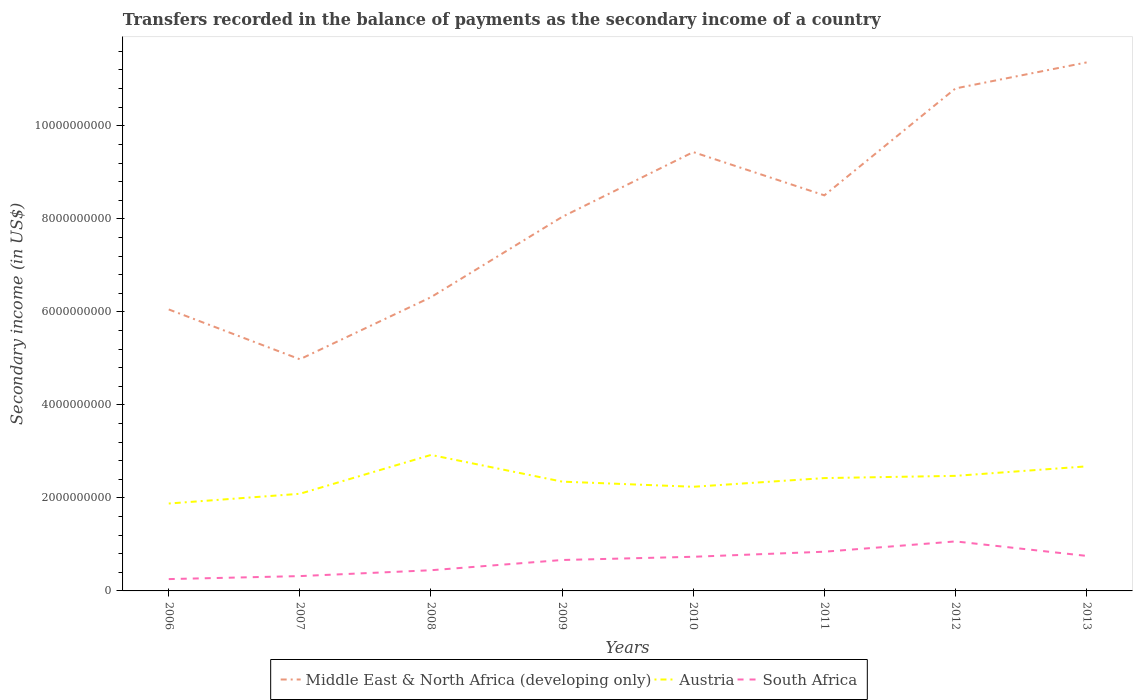Is the number of lines equal to the number of legend labels?
Give a very brief answer. Yes. Across all years, what is the maximum secondary income of in South Africa?
Keep it short and to the point. 2.54e+08. What is the total secondary income of in Middle East & North Africa (developing only) in the graph?
Offer a terse response. -5.31e+09. What is the difference between the highest and the second highest secondary income of in Austria?
Your response must be concise. 1.04e+09. What is the difference between the highest and the lowest secondary income of in Austria?
Offer a very short reply. 4. Is the secondary income of in Middle East & North Africa (developing only) strictly greater than the secondary income of in Austria over the years?
Make the answer very short. No. How many lines are there?
Your answer should be compact. 3. Does the graph contain any zero values?
Make the answer very short. No. How many legend labels are there?
Offer a terse response. 3. How are the legend labels stacked?
Your answer should be very brief. Horizontal. What is the title of the graph?
Offer a very short reply. Transfers recorded in the balance of payments as the secondary income of a country. Does "St. Kitts and Nevis" appear as one of the legend labels in the graph?
Your response must be concise. No. What is the label or title of the Y-axis?
Your answer should be very brief. Secondary income (in US$). What is the Secondary income (in US$) of Middle East & North Africa (developing only) in 2006?
Provide a succinct answer. 6.05e+09. What is the Secondary income (in US$) in Austria in 2006?
Provide a short and direct response. 1.88e+09. What is the Secondary income (in US$) of South Africa in 2006?
Ensure brevity in your answer.  2.54e+08. What is the Secondary income (in US$) of Middle East & North Africa (developing only) in 2007?
Your answer should be compact. 4.98e+09. What is the Secondary income (in US$) in Austria in 2007?
Your answer should be compact. 2.09e+09. What is the Secondary income (in US$) in South Africa in 2007?
Make the answer very short. 3.19e+08. What is the Secondary income (in US$) in Middle East & North Africa (developing only) in 2008?
Provide a succinct answer. 6.32e+09. What is the Secondary income (in US$) of Austria in 2008?
Your answer should be compact. 2.92e+09. What is the Secondary income (in US$) of South Africa in 2008?
Your response must be concise. 4.45e+08. What is the Secondary income (in US$) in Middle East & North Africa (developing only) in 2009?
Offer a terse response. 8.04e+09. What is the Secondary income (in US$) of Austria in 2009?
Provide a short and direct response. 2.35e+09. What is the Secondary income (in US$) of South Africa in 2009?
Make the answer very short. 6.65e+08. What is the Secondary income (in US$) of Middle East & North Africa (developing only) in 2010?
Your answer should be very brief. 9.43e+09. What is the Secondary income (in US$) of Austria in 2010?
Make the answer very short. 2.24e+09. What is the Secondary income (in US$) in South Africa in 2010?
Make the answer very short. 7.34e+08. What is the Secondary income (in US$) of Middle East & North Africa (developing only) in 2011?
Make the answer very short. 8.50e+09. What is the Secondary income (in US$) of Austria in 2011?
Your answer should be very brief. 2.43e+09. What is the Secondary income (in US$) in South Africa in 2011?
Provide a succinct answer. 8.43e+08. What is the Secondary income (in US$) of Middle East & North Africa (developing only) in 2012?
Your answer should be compact. 1.08e+1. What is the Secondary income (in US$) in Austria in 2012?
Give a very brief answer. 2.47e+09. What is the Secondary income (in US$) of South Africa in 2012?
Give a very brief answer. 1.06e+09. What is the Secondary income (in US$) in Middle East & North Africa (developing only) in 2013?
Keep it short and to the point. 1.14e+1. What is the Secondary income (in US$) of Austria in 2013?
Make the answer very short. 2.68e+09. What is the Secondary income (in US$) in South Africa in 2013?
Give a very brief answer. 7.53e+08. Across all years, what is the maximum Secondary income (in US$) in Middle East & North Africa (developing only)?
Keep it short and to the point. 1.14e+1. Across all years, what is the maximum Secondary income (in US$) of Austria?
Your response must be concise. 2.92e+09. Across all years, what is the maximum Secondary income (in US$) in South Africa?
Your answer should be very brief. 1.06e+09. Across all years, what is the minimum Secondary income (in US$) of Middle East & North Africa (developing only)?
Provide a succinct answer. 4.98e+09. Across all years, what is the minimum Secondary income (in US$) of Austria?
Offer a very short reply. 1.88e+09. Across all years, what is the minimum Secondary income (in US$) in South Africa?
Keep it short and to the point. 2.54e+08. What is the total Secondary income (in US$) of Middle East & North Africa (developing only) in the graph?
Give a very brief answer. 6.55e+1. What is the total Secondary income (in US$) of Austria in the graph?
Your response must be concise. 1.91e+1. What is the total Secondary income (in US$) of South Africa in the graph?
Your response must be concise. 5.08e+09. What is the difference between the Secondary income (in US$) in Middle East & North Africa (developing only) in 2006 and that in 2007?
Ensure brevity in your answer.  1.07e+09. What is the difference between the Secondary income (in US$) in Austria in 2006 and that in 2007?
Ensure brevity in your answer.  -2.09e+08. What is the difference between the Secondary income (in US$) in South Africa in 2006 and that in 2007?
Provide a short and direct response. -6.44e+07. What is the difference between the Secondary income (in US$) in Middle East & North Africa (developing only) in 2006 and that in 2008?
Ensure brevity in your answer.  -2.64e+08. What is the difference between the Secondary income (in US$) in Austria in 2006 and that in 2008?
Your response must be concise. -1.04e+09. What is the difference between the Secondary income (in US$) in South Africa in 2006 and that in 2008?
Offer a terse response. -1.90e+08. What is the difference between the Secondary income (in US$) of Middle East & North Africa (developing only) in 2006 and that in 2009?
Ensure brevity in your answer.  -1.99e+09. What is the difference between the Secondary income (in US$) in Austria in 2006 and that in 2009?
Offer a terse response. -4.71e+08. What is the difference between the Secondary income (in US$) of South Africa in 2006 and that in 2009?
Provide a succinct answer. -4.10e+08. What is the difference between the Secondary income (in US$) in Middle East & North Africa (developing only) in 2006 and that in 2010?
Keep it short and to the point. -3.38e+09. What is the difference between the Secondary income (in US$) in Austria in 2006 and that in 2010?
Keep it short and to the point. -3.60e+08. What is the difference between the Secondary income (in US$) of South Africa in 2006 and that in 2010?
Provide a succinct answer. -4.80e+08. What is the difference between the Secondary income (in US$) of Middle East & North Africa (developing only) in 2006 and that in 2011?
Provide a short and direct response. -2.45e+09. What is the difference between the Secondary income (in US$) of Austria in 2006 and that in 2011?
Provide a short and direct response. -5.47e+08. What is the difference between the Secondary income (in US$) in South Africa in 2006 and that in 2011?
Offer a terse response. -5.89e+08. What is the difference between the Secondary income (in US$) of Middle East & North Africa (developing only) in 2006 and that in 2012?
Ensure brevity in your answer.  -4.75e+09. What is the difference between the Secondary income (in US$) in Austria in 2006 and that in 2012?
Offer a very short reply. -5.95e+08. What is the difference between the Secondary income (in US$) in South Africa in 2006 and that in 2012?
Ensure brevity in your answer.  -8.10e+08. What is the difference between the Secondary income (in US$) of Middle East & North Africa (developing only) in 2006 and that in 2013?
Offer a terse response. -5.31e+09. What is the difference between the Secondary income (in US$) of Austria in 2006 and that in 2013?
Make the answer very short. -7.99e+08. What is the difference between the Secondary income (in US$) of South Africa in 2006 and that in 2013?
Ensure brevity in your answer.  -4.99e+08. What is the difference between the Secondary income (in US$) of Middle East & North Africa (developing only) in 2007 and that in 2008?
Provide a short and direct response. -1.34e+09. What is the difference between the Secondary income (in US$) in Austria in 2007 and that in 2008?
Provide a succinct answer. -8.35e+08. What is the difference between the Secondary income (in US$) in South Africa in 2007 and that in 2008?
Your answer should be very brief. -1.26e+08. What is the difference between the Secondary income (in US$) in Middle East & North Africa (developing only) in 2007 and that in 2009?
Keep it short and to the point. -3.06e+09. What is the difference between the Secondary income (in US$) of Austria in 2007 and that in 2009?
Provide a succinct answer. -2.61e+08. What is the difference between the Secondary income (in US$) of South Africa in 2007 and that in 2009?
Offer a terse response. -3.46e+08. What is the difference between the Secondary income (in US$) in Middle East & North Africa (developing only) in 2007 and that in 2010?
Ensure brevity in your answer.  -4.45e+09. What is the difference between the Secondary income (in US$) of Austria in 2007 and that in 2010?
Your answer should be very brief. -1.51e+08. What is the difference between the Secondary income (in US$) in South Africa in 2007 and that in 2010?
Keep it short and to the point. -4.15e+08. What is the difference between the Secondary income (in US$) of Middle East & North Africa (developing only) in 2007 and that in 2011?
Your answer should be compact. -3.52e+09. What is the difference between the Secondary income (in US$) of Austria in 2007 and that in 2011?
Your answer should be compact. -3.38e+08. What is the difference between the Secondary income (in US$) of South Africa in 2007 and that in 2011?
Offer a terse response. -5.24e+08. What is the difference between the Secondary income (in US$) in Middle East & North Africa (developing only) in 2007 and that in 2012?
Make the answer very short. -5.82e+09. What is the difference between the Secondary income (in US$) of Austria in 2007 and that in 2012?
Give a very brief answer. -3.85e+08. What is the difference between the Secondary income (in US$) in South Africa in 2007 and that in 2012?
Your response must be concise. -7.46e+08. What is the difference between the Secondary income (in US$) of Middle East & North Africa (developing only) in 2007 and that in 2013?
Your answer should be very brief. -6.38e+09. What is the difference between the Secondary income (in US$) in Austria in 2007 and that in 2013?
Make the answer very short. -5.90e+08. What is the difference between the Secondary income (in US$) in South Africa in 2007 and that in 2013?
Offer a very short reply. -4.34e+08. What is the difference between the Secondary income (in US$) in Middle East & North Africa (developing only) in 2008 and that in 2009?
Make the answer very short. -1.73e+09. What is the difference between the Secondary income (in US$) in Austria in 2008 and that in 2009?
Offer a terse response. 5.74e+08. What is the difference between the Secondary income (in US$) in South Africa in 2008 and that in 2009?
Your answer should be compact. -2.20e+08. What is the difference between the Secondary income (in US$) of Middle East & North Africa (developing only) in 2008 and that in 2010?
Provide a short and direct response. -3.12e+09. What is the difference between the Secondary income (in US$) of Austria in 2008 and that in 2010?
Offer a terse response. 6.85e+08. What is the difference between the Secondary income (in US$) in South Africa in 2008 and that in 2010?
Make the answer very short. -2.90e+08. What is the difference between the Secondary income (in US$) in Middle East & North Africa (developing only) in 2008 and that in 2011?
Keep it short and to the point. -2.19e+09. What is the difference between the Secondary income (in US$) of Austria in 2008 and that in 2011?
Ensure brevity in your answer.  4.98e+08. What is the difference between the Secondary income (in US$) in South Africa in 2008 and that in 2011?
Keep it short and to the point. -3.98e+08. What is the difference between the Secondary income (in US$) of Middle East & North Africa (developing only) in 2008 and that in 2012?
Provide a short and direct response. -4.49e+09. What is the difference between the Secondary income (in US$) in Austria in 2008 and that in 2012?
Give a very brief answer. 4.50e+08. What is the difference between the Secondary income (in US$) in South Africa in 2008 and that in 2012?
Give a very brief answer. -6.20e+08. What is the difference between the Secondary income (in US$) of Middle East & North Africa (developing only) in 2008 and that in 2013?
Keep it short and to the point. -5.05e+09. What is the difference between the Secondary income (in US$) in Austria in 2008 and that in 2013?
Make the answer very short. 2.46e+08. What is the difference between the Secondary income (in US$) of South Africa in 2008 and that in 2013?
Your answer should be very brief. -3.08e+08. What is the difference between the Secondary income (in US$) in Middle East & North Africa (developing only) in 2009 and that in 2010?
Your answer should be very brief. -1.39e+09. What is the difference between the Secondary income (in US$) of Austria in 2009 and that in 2010?
Your answer should be compact. 1.11e+08. What is the difference between the Secondary income (in US$) in South Africa in 2009 and that in 2010?
Offer a very short reply. -6.94e+07. What is the difference between the Secondary income (in US$) of Middle East & North Africa (developing only) in 2009 and that in 2011?
Keep it short and to the point. -4.64e+08. What is the difference between the Secondary income (in US$) in Austria in 2009 and that in 2011?
Keep it short and to the point. -7.61e+07. What is the difference between the Secondary income (in US$) of South Africa in 2009 and that in 2011?
Make the answer very short. -1.78e+08. What is the difference between the Secondary income (in US$) in Middle East & North Africa (developing only) in 2009 and that in 2012?
Ensure brevity in your answer.  -2.76e+09. What is the difference between the Secondary income (in US$) of Austria in 2009 and that in 2012?
Your response must be concise. -1.24e+08. What is the difference between the Secondary income (in US$) of South Africa in 2009 and that in 2012?
Provide a succinct answer. -4.00e+08. What is the difference between the Secondary income (in US$) of Middle East & North Africa (developing only) in 2009 and that in 2013?
Your answer should be very brief. -3.32e+09. What is the difference between the Secondary income (in US$) of Austria in 2009 and that in 2013?
Offer a very short reply. -3.28e+08. What is the difference between the Secondary income (in US$) of South Africa in 2009 and that in 2013?
Offer a very short reply. -8.82e+07. What is the difference between the Secondary income (in US$) of Middle East & North Africa (developing only) in 2010 and that in 2011?
Your response must be concise. 9.30e+08. What is the difference between the Secondary income (in US$) of Austria in 2010 and that in 2011?
Your response must be concise. -1.87e+08. What is the difference between the Secondary income (in US$) in South Africa in 2010 and that in 2011?
Your answer should be very brief. -1.09e+08. What is the difference between the Secondary income (in US$) in Middle East & North Africa (developing only) in 2010 and that in 2012?
Your answer should be compact. -1.37e+09. What is the difference between the Secondary income (in US$) of Austria in 2010 and that in 2012?
Your answer should be very brief. -2.35e+08. What is the difference between the Secondary income (in US$) in South Africa in 2010 and that in 2012?
Offer a very short reply. -3.30e+08. What is the difference between the Secondary income (in US$) of Middle East & North Africa (developing only) in 2010 and that in 2013?
Your response must be concise. -1.93e+09. What is the difference between the Secondary income (in US$) in Austria in 2010 and that in 2013?
Make the answer very short. -4.39e+08. What is the difference between the Secondary income (in US$) in South Africa in 2010 and that in 2013?
Offer a very short reply. -1.88e+07. What is the difference between the Secondary income (in US$) of Middle East & North Africa (developing only) in 2011 and that in 2012?
Keep it short and to the point. -2.30e+09. What is the difference between the Secondary income (in US$) in Austria in 2011 and that in 2012?
Your answer should be compact. -4.79e+07. What is the difference between the Secondary income (in US$) of South Africa in 2011 and that in 2012?
Give a very brief answer. -2.21e+08. What is the difference between the Secondary income (in US$) of Middle East & North Africa (developing only) in 2011 and that in 2013?
Keep it short and to the point. -2.86e+09. What is the difference between the Secondary income (in US$) in Austria in 2011 and that in 2013?
Provide a short and direct response. -2.52e+08. What is the difference between the Secondary income (in US$) in South Africa in 2011 and that in 2013?
Keep it short and to the point. 9.01e+07. What is the difference between the Secondary income (in US$) of Middle East & North Africa (developing only) in 2012 and that in 2013?
Offer a very short reply. -5.59e+08. What is the difference between the Secondary income (in US$) of Austria in 2012 and that in 2013?
Give a very brief answer. -2.04e+08. What is the difference between the Secondary income (in US$) of South Africa in 2012 and that in 2013?
Offer a terse response. 3.11e+08. What is the difference between the Secondary income (in US$) in Middle East & North Africa (developing only) in 2006 and the Secondary income (in US$) in Austria in 2007?
Give a very brief answer. 3.96e+09. What is the difference between the Secondary income (in US$) of Middle East & North Africa (developing only) in 2006 and the Secondary income (in US$) of South Africa in 2007?
Your response must be concise. 5.73e+09. What is the difference between the Secondary income (in US$) in Austria in 2006 and the Secondary income (in US$) in South Africa in 2007?
Offer a very short reply. 1.56e+09. What is the difference between the Secondary income (in US$) of Middle East & North Africa (developing only) in 2006 and the Secondary income (in US$) of Austria in 2008?
Provide a succinct answer. 3.13e+09. What is the difference between the Secondary income (in US$) of Middle East & North Africa (developing only) in 2006 and the Secondary income (in US$) of South Africa in 2008?
Provide a succinct answer. 5.61e+09. What is the difference between the Secondary income (in US$) of Austria in 2006 and the Secondary income (in US$) of South Africa in 2008?
Provide a succinct answer. 1.43e+09. What is the difference between the Secondary income (in US$) of Middle East & North Africa (developing only) in 2006 and the Secondary income (in US$) of Austria in 2009?
Your response must be concise. 3.70e+09. What is the difference between the Secondary income (in US$) of Middle East & North Africa (developing only) in 2006 and the Secondary income (in US$) of South Africa in 2009?
Offer a very short reply. 5.39e+09. What is the difference between the Secondary income (in US$) of Austria in 2006 and the Secondary income (in US$) of South Africa in 2009?
Your answer should be very brief. 1.21e+09. What is the difference between the Secondary income (in US$) in Middle East & North Africa (developing only) in 2006 and the Secondary income (in US$) in Austria in 2010?
Ensure brevity in your answer.  3.81e+09. What is the difference between the Secondary income (in US$) in Middle East & North Africa (developing only) in 2006 and the Secondary income (in US$) in South Africa in 2010?
Provide a short and direct response. 5.32e+09. What is the difference between the Secondary income (in US$) in Austria in 2006 and the Secondary income (in US$) in South Africa in 2010?
Offer a very short reply. 1.14e+09. What is the difference between the Secondary income (in US$) of Middle East & North Africa (developing only) in 2006 and the Secondary income (in US$) of Austria in 2011?
Provide a succinct answer. 3.63e+09. What is the difference between the Secondary income (in US$) in Middle East & North Africa (developing only) in 2006 and the Secondary income (in US$) in South Africa in 2011?
Give a very brief answer. 5.21e+09. What is the difference between the Secondary income (in US$) of Austria in 2006 and the Secondary income (in US$) of South Africa in 2011?
Offer a very short reply. 1.04e+09. What is the difference between the Secondary income (in US$) in Middle East & North Africa (developing only) in 2006 and the Secondary income (in US$) in Austria in 2012?
Provide a short and direct response. 3.58e+09. What is the difference between the Secondary income (in US$) in Middle East & North Africa (developing only) in 2006 and the Secondary income (in US$) in South Africa in 2012?
Ensure brevity in your answer.  4.99e+09. What is the difference between the Secondary income (in US$) of Austria in 2006 and the Secondary income (in US$) of South Africa in 2012?
Your answer should be compact. 8.15e+08. What is the difference between the Secondary income (in US$) of Middle East & North Africa (developing only) in 2006 and the Secondary income (in US$) of Austria in 2013?
Your answer should be compact. 3.37e+09. What is the difference between the Secondary income (in US$) in Middle East & North Africa (developing only) in 2006 and the Secondary income (in US$) in South Africa in 2013?
Keep it short and to the point. 5.30e+09. What is the difference between the Secondary income (in US$) of Austria in 2006 and the Secondary income (in US$) of South Africa in 2013?
Your answer should be compact. 1.13e+09. What is the difference between the Secondary income (in US$) of Middle East & North Africa (developing only) in 2007 and the Secondary income (in US$) of Austria in 2008?
Your response must be concise. 2.06e+09. What is the difference between the Secondary income (in US$) of Middle East & North Africa (developing only) in 2007 and the Secondary income (in US$) of South Africa in 2008?
Offer a very short reply. 4.54e+09. What is the difference between the Secondary income (in US$) in Austria in 2007 and the Secondary income (in US$) in South Africa in 2008?
Keep it short and to the point. 1.64e+09. What is the difference between the Secondary income (in US$) of Middle East & North Africa (developing only) in 2007 and the Secondary income (in US$) of Austria in 2009?
Your response must be concise. 2.63e+09. What is the difference between the Secondary income (in US$) of Middle East & North Africa (developing only) in 2007 and the Secondary income (in US$) of South Africa in 2009?
Offer a very short reply. 4.32e+09. What is the difference between the Secondary income (in US$) of Austria in 2007 and the Secondary income (in US$) of South Africa in 2009?
Provide a succinct answer. 1.42e+09. What is the difference between the Secondary income (in US$) in Middle East & North Africa (developing only) in 2007 and the Secondary income (in US$) in Austria in 2010?
Your answer should be very brief. 2.74e+09. What is the difference between the Secondary income (in US$) of Middle East & North Africa (developing only) in 2007 and the Secondary income (in US$) of South Africa in 2010?
Give a very brief answer. 4.25e+09. What is the difference between the Secondary income (in US$) in Austria in 2007 and the Secondary income (in US$) in South Africa in 2010?
Provide a short and direct response. 1.35e+09. What is the difference between the Secondary income (in US$) of Middle East & North Africa (developing only) in 2007 and the Secondary income (in US$) of Austria in 2011?
Your answer should be compact. 2.55e+09. What is the difference between the Secondary income (in US$) in Middle East & North Africa (developing only) in 2007 and the Secondary income (in US$) in South Africa in 2011?
Ensure brevity in your answer.  4.14e+09. What is the difference between the Secondary income (in US$) of Austria in 2007 and the Secondary income (in US$) of South Africa in 2011?
Keep it short and to the point. 1.25e+09. What is the difference between the Secondary income (in US$) in Middle East & North Africa (developing only) in 2007 and the Secondary income (in US$) in Austria in 2012?
Your answer should be compact. 2.51e+09. What is the difference between the Secondary income (in US$) in Middle East & North Africa (developing only) in 2007 and the Secondary income (in US$) in South Africa in 2012?
Offer a terse response. 3.92e+09. What is the difference between the Secondary income (in US$) of Austria in 2007 and the Secondary income (in US$) of South Africa in 2012?
Make the answer very short. 1.02e+09. What is the difference between the Secondary income (in US$) of Middle East & North Africa (developing only) in 2007 and the Secondary income (in US$) of Austria in 2013?
Keep it short and to the point. 2.30e+09. What is the difference between the Secondary income (in US$) of Middle East & North Africa (developing only) in 2007 and the Secondary income (in US$) of South Africa in 2013?
Your answer should be very brief. 4.23e+09. What is the difference between the Secondary income (in US$) of Austria in 2007 and the Secondary income (in US$) of South Africa in 2013?
Your response must be concise. 1.34e+09. What is the difference between the Secondary income (in US$) of Middle East & North Africa (developing only) in 2008 and the Secondary income (in US$) of Austria in 2009?
Provide a short and direct response. 3.97e+09. What is the difference between the Secondary income (in US$) in Middle East & North Africa (developing only) in 2008 and the Secondary income (in US$) in South Africa in 2009?
Keep it short and to the point. 5.65e+09. What is the difference between the Secondary income (in US$) of Austria in 2008 and the Secondary income (in US$) of South Africa in 2009?
Ensure brevity in your answer.  2.26e+09. What is the difference between the Secondary income (in US$) of Middle East & North Africa (developing only) in 2008 and the Secondary income (in US$) of Austria in 2010?
Keep it short and to the point. 4.08e+09. What is the difference between the Secondary income (in US$) of Middle East & North Africa (developing only) in 2008 and the Secondary income (in US$) of South Africa in 2010?
Give a very brief answer. 5.58e+09. What is the difference between the Secondary income (in US$) of Austria in 2008 and the Secondary income (in US$) of South Africa in 2010?
Your response must be concise. 2.19e+09. What is the difference between the Secondary income (in US$) in Middle East & North Africa (developing only) in 2008 and the Secondary income (in US$) in Austria in 2011?
Provide a succinct answer. 3.89e+09. What is the difference between the Secondary income (in US$) of Middle East & North Africa (developing only) in 2008 and the Secondary income (in US$) of South Africa in 2011?
Offer a terse response. 5.47e+09. What is the difference between the Secondary income (in US$) in Austria in 2008 and the Secondary income (in US$) in South Africa in 2011?
Ensure brevity in your answer.  2.08e+09. What is the difference between the Secondary income (in US$) of Middle East & North Africa (developing only) in 2008 and the Secondary income (in US$) of Austria in 2012?
Keep it short and to the point. 3.84e+09. What is the difference between the Secondary income (in US$) of Middle East & North Africa (developing only) in 2008 and the Secondary income (in US$) of South Africa in 2012?
Ensure brevity in your answer.  5.25e+09. What is the difference between the Secondary income (in US$) of Austria in 2008 and the Secondary income (in US$) of South Africa in 2012?
Give a very brief answer. 1.86e+09. What is the difference between the Secondary income (in US$) in Middle East & North Africa (developing only) in 2008 and the Secondary income (in US$) in Austria in 2013?
Provide a succinct answer. 3.64e+09. What is the difference between the Secondary income (in US$) in Middle East & North Africa (developing only) in 2008 and the Secondary income (in US$) in South Africa in 2013?
Offer a very short reply. 5.56e+09. What is the difference between the Secondary income (in US$) of Austria in 2008 and the Secondary income (in US$) of South Africa in 2013?
Provide a succinct answer. 2.17e+09. What is the difference between the Secondary income (in US$) in Middle East & North Africa (developing only) in 2009 and the Secondary income (in US$) in Austria in 2010?
Provide a succinct answer. 5.80e+09. What is the difference between the Secondary income (in US$) of Middle East & North Africa (developing only) in 2009 and the Secondary income (in US$) of South Africa in 2010?
Your answer should be very brief. 7.31e+09. What is the difference between the Secondary income (in US$) in Austria in 2009 and the Secondary income (in US$) in South Africa in 2010?
Keep it short and to the point. 1.62e+09. What is the difference between the Secondary income (in US$) in Middle East & North Africa (developing only) in 2009 and the Secondary income (in US$) in Austria in 2011?
Your answer should be very brief. 5.62e+09. What is the difference between the Secondary income (in US$) in Middle East & North Africa (developing only) in 2009 and the Secondary income (in US$) in South Africa in 2011?
Offer a terse response. 7.20e+09. What is the difference between the Secondary income (in US$) of Austria in 2009 and the Secondary income (in US$) of South Africa in 2011?
Offer a terse response. 1.51e+09. What is the difference between the Secondary income (in US$) of Middle East & North Africa (developing only) in 2009 and the Secondary income (in US$) of Austria in 2012?
Provide a succinct answer. 5.57e+09. What is the difference between the Secondary income (in US$) of Middle East & North Africa (developing only) in 2009 and the Secondary income (in US$) of South Africa in 2012?
Ensure brevity in your answer.  6.98e+09. What is the difference between the Secondary income (in US$) in Austria in 2009 and the Secondary income (in US$) in South Africa in 2012?
Ensure brevity in your answer.  1.29e+09. What is the difference between the Secondary income (in US$) in Middle East & North Africa (developing only) in 2009 and the Secondary income (in US$) in Austria in 2013?
Make the answer very short. 5.36e+09. What is the difference between the Secondary income (in US$) in Middle East & North Africa (developing only) in 2009 and the Secondary income (in US$) in South Africa in 2013?
Make the answer very short. 7.29e+09. What is the difference between the Secondary income (in US$) in Austria in 2009 and the Secondary income (in US$) in South Africa in 2013?
Give a very brief answer. 1.60e+09. What is the difference between the Secondary income (in US$) in Middle East & North Africa (developing only) in 2010 and the Secondary income (in US$) in Austria in 2011?
Keep it short and to the point. 7.01e+09. What is the difference between the Secondary income (in US$) in Middle East & North Africa (developing only) in 2010 and the Secondary income (in US$) in South Africa in 2011?
Your answer should be compact. 8.59e+09. What is the difference between the Secondary income (in US$) of Austria in 2010 and the Secondary income (in US$) of South Africa in 2011?
Offer a very short reply. 1.40e+09. What is the difference between the Secondary income (in US$) of Middle East & North Africa (developing only) in 2010 and the Secondary income (in US$) of Austria in 2012?
Your answer should be very brief. 6.96e+09. What is the difference between the Secondary income (in US$) in Middle East & North Africa (developing only) in 2010 and the Secondary income (in US$) in South Africa in 2012?
Your response must be concise. 8.37e+09. What is the difference between the Secondary income (in US$) of Austria in 2010 and the Secondary income (in US$) of South Africa in 2012?
Offer a very short reply. 1.17e+09. What is the difference between the Secondary income (in US$) in Middle East & North Africa (developing only) in 2010 and the Secondary income (in US$) in Austria in 2013?
Offer a terse response. 6.76e+09. What is the difference between the Secondary income (in US$) in Middle East & North Africa (developing only) in 2010 and the Secondary income (in US$) in South Africa in 2013?
Make the answer very short. 8.68e+09. What is the difference between the Secondary income (in US$) of Austria in 2010 and the Secondary income (in US$) of South Africa in 2013?
Provide a short and direct response. 1.49e+09. What is the difference between the Secondary income (in US$) in Middle East & North Africa (developing only) in 2011 and the Secondary income (in US$) in Austria in 2012?
Your response must be concise. 6.03e+09. What is the difference between the Secondary income (in US$) of Middle East & North Africa (developing only) in 2011 and the Secondary income (in US$) of South Africa in 2012?
Your answer should be compact. 7.44e+09. What is the difference between the Secondary income (in US$) of Austria in 2011 and the Secondary income (in US$) of South Africa in 2012?
Ensure brevity in your answer.  1.36e+09. What is the difference between the Secondary income (in US$) in Middle East & North Africa (developing only) in 2011 and the Secondary income (in US$) in Austria in 2013?
Offer a terse response. 5.83e+09. What is the difference between the Secondary income (in US$) in Middle East & North Africa (developing only) in 2011 and the Secondary income (in US$) in South Africa in 2013?
Ensure brevity in your answer.  7.75e+09. What is the difference between the Secondary income (in US$) of Austria in 2011 and the Secondary income (in US$) of South Africa in 2013?
Offer a very short reply. 1.67e+09. What is the difference between the Secondary income (in US$) in Middle East & North Africa (developing only) in 2012 and the Secondary income (in US$) in Austria in 2013?
Give a very brief answer. 8.13e+09. What is the difference between the Secondary income (in US$) in Middle East & North Africa (developing only) in 2012 and the Secondary income (in US$) in South Africa in 2013?
Keep it short and to the point. 1.01e+1. What is the difference between the Secondary income (in US$) in Austria in 2012 and the Secondary income (in US$) in South Africa in 2013?
Make the answer very short. 1.72e+09. What is the average Secondary income (in US$) of Middle East & North Africa (developing only) per year?
Your answer should be very brief. 8.19e+09. What is the average Secondary income (in US$) in Austria per year?
Offer a terse response. 2.38e+09. What is the average Secondary income (in US$) of South Africa per year?
Provide a succinct answer. 6.35e+08. In the year 2006, what is the difference between the Secondary income (in US$) of Middle East & North Africa (developing only) and Secondary income (in US$) of Austria?
Provide a short and direct response. 4.17e+09. In the year 2006, what is the difference between the Secondary income (in US$) of Middle East & North Africa (developing only) and Secondary income (in US$) of South Africa?
Your response must be concise. 5.80e+09. In the year 2006, what is the difference between the Secondary income (in US$) in Austria and Secondary income (in US$) in South Africa?
Give a very brief answer. 1.62e+09. In the year 2007, what is the difference between the Secondary income (in US$) of Middle East & North Africa (developing only) and Secondary income (in US$) of Austria?
Offer a very short reply. 2.89e+09. In the year 2007, what is the difference between the Secondary income (in US$) of Middle East & North Africa (developing only) and Secondary income (in US$) of South Africa?
Offer a very short reply. 4.66e+09. In the year 2007, what is the difference between the Secondary income (in US$) in Austria and Secondary income (in US$) in South Africa?
Ensure brevity in your answer.  1.77e+09. In the year 2008, what is the difference between the Secondary income (in US$) of Middle East & North Africa (developing only) and Secondary income (in US$) of Austria?
Provide a short and direct response. 3.39e+09. In the year 2008, what is the difference between the Secondary income (in US$) of Middle East & North Africa (developing only) and Secondary income (in US$) of South Africa?
Your answer should be very brief. 5.87e+09. In the year 2008, what is the difference between the Secondary income (in US$) in Austria and Secondary income (in US$) in South Africa?
Give a very brief answer. 2.48e+09. In the year 2009, what is the difference between the Secondary income (in US$) of Middle East & North Africa (developing only) and Secondary income (in US$) of Austria?
Make the answer very short. 5.69e+09. In the year 2009, what is the difference between the Secondary income (in US$) in Middle East & North Africa (developing only) and Secondary income (in US$) in South Africa?
Your answer should be very brief. 7.38e+09. In the year 2009, what is the difference between the Secondary income (in US$) of Austria and Secondary income (in US$) of South Africa?
Offer a very short reply. 1.69e+09. In the year 2010, what is the difference between the Secondary income (in US$) of Middle East & North Africa (developing only) and Secondary income (in US$) of Austria?
Make the answer very short. 7.20e+09. In the year 2010, what is the difference between the Secondary income (in US$) in Middle East & North Africa (developing only) and Secondary income (in US$) in South Africa?
Your answer should be very brief. 8.70e+09. In the year 2010, what is the difference between the Secondary income (in US$) in Austria and Secondary income (in US$) in South Africa?
Provide a succinct answer. 1.50e+09. In the year 2011, what is the difference between the Secondary income (in US$) of Middle East & North Africa (developing only) and Secondary income (in US$) of Austria?
Ensure brevity in your answer.  6.08e+09. In the year 2011, what is the difference between the Secondary income (in US$) of Middle East & North Africa (developing only) and Secondary income (in US$) of South Africa?
Your answer should be very brief. 7.66e+09. In the year 2011, what is the difference between the Secondary income (in US$) in Austria and Secondary income (in US$) in South Africa?
Your answer should be very brief. 1.58e+09. In the year 2012, what is the difference between the Secondary income (in US$) in Middle East & North Africa (developing only) and Secondary income (in US$) in Austria?
Provide a short and direct response. 8.33e+09. In the year 2012, what is the difference between the Secondary income (in US$) of Middle East & North Africa (developing only) and Secondary income (in US$) of South Africa?
Provide a succinct answer. 9.74e+09. In the year 2012, what is the difference between the Secondary income (in US$) of Austria and Secondary income (in US$) of South Africa?
Keep it short and to the point. 1.41e+09. In the year 2013, what is the difference between the Secondary income (in US$) of Middle East & North Africa (developing only) and Secondary income (in US$) of Austria?
Offer a terse response. 8.68e+09. In the year 2013, what is the difference between the Secondary income (in US$) of Middle East & North Africa (developing only) and Secondary income (in US$) of South Africa?
Your answer should be compact. 1.06e+1. In the year 2013, what is the difference between the Secondary income (in US$) of Austria and Secondary income (in US$) of South Africa?
Offer a terse response. 1.93e+09. What is the ratio of the Secondary income (in US$) in Middle East & North Africa (developing only) in 2006 to that in 2007?
Your answer should be compact. 1.22. What is the ratio of the Secondary income (in US$) in Austria in 2006 to that in 2007?
Provide a succinct answer. 0.9. What is the ratio of the Secondary income (in US$) in South Africa in 2006 to that in 2007?
Provide a short and direct response. 0.8. What is the ratio of the Secondary income (in US$) of Middle East & North Africa (developing only) in 2006 to that in 2008?
Offer a very short reply. 0.96. What is the ratio of the Secondary income (in US$) of Austria in 2006 to that in 2008?
Offer a very short reply. 0.64. What is the ratio of the Secondary income (in US$) in South Africa in 2006 to that in 2008?
Give a very brief answer. 0.57. What is the ratio of the Secondary income (in US$) of Middle East & North Africa (developing only) in 2006 to that in 2009?
Your response must be concise. 0.75. What is the ratio of the Secondary income (in US$) of Austria in 2006 to that in 2009?
Offer a very short reply. 0.8. What is the ratio of the Secondary income (in US$) of South Africa in 2006 to that in 2009?
Provide a succinct answer. 0.38. What is the ratio of the Secondary income (in US$) of Middle East & North Africa (developing only) in 2006 to that in 2010?
Offer a very short reply. 0.64. What is the ratio of the Secondary income (in US$) of Austria in 2006 to that in 2010?
Provide a short and direct response. 0.84. What is the ratio of the Secondary income (in US$) of South Africa in 2006 to that in 2010?
Offer a very short reply. 0.35. What is the ratio of the Secondary income (in US$) in Middle East & North Africa (developing only) in 2006 to that in 2011?
Provide a short and direct response. 0.71. What is the ratio of the Secondary income (in US$) in Austria in 2006 to that in 2011?
Ensure brevity in your answer.  0.77. What is the ratio of the Secondary income (in US$) of South Africa in 2006 to that in 2011?
Your answer should be compact. 0.3. What is the ratio of the Secondary income (in US$) in Middle East & North Africa (developing only) in 2006 to that in 2012?
Ensure brevity in your answer.  0.56. What is the ratio of the Secondary income (in US$) in Austria in 2006 to that in 2012?
Offer a terse response. 0.76. What is the ratio of the Secondary income (in US$) of South Africa in 2006 to that in 2012?
Your answer should be very brief. 0.24. What is the ratio of the Secondary income (in US$) of Middle East & North Africa (developing only) in 2006 to that in 2013?
Offer a very short reply. 0.53. What is the ratio of the Secondary income (in US$) in Austria in 2006 to that in 2013?
Your response must be concise. 0.7. What is the ratio of the Secondary income (in US$) in South Africa in 2006 to that in 2013?
Your answer should be compact. 0.34. What is the ratio of the Secondary income (in US$) in Middle East & North Africa (developing only) in 2007 to that in 2008?
Ensure brevity in your answer.  0.79. What is the ratio of the Secondary income (in US$) of South Africa in 2007 to that in 2008?
Ensure brevity in your answer.  0.72. What is the ratio of the Secondary income (in US$) in Middle East & North Africa (developing only) in 2007 to that in 2009?
Keep it short and to the point. 0.62. What is the ratio of the Secondary income (in US$) in Austria in 2007 to that in 2009?
Ensure brevity in your answer.  0.89. What is the ratio of the Secondary income (in US$) of South Africa in 2007 to that in 2009?
Offer a terse response. 0.48. What is the ratio of the Secondary income (in US$) in Middle East & North Africa (developing only) in 2007 to that in 2010?
Offer a terse response. 0.53. What is the ratio of the Secondary income (in US$) in Austria in 2007 to that in 2010?
Provide a short and direct response. 0.93. What is the ratio of the Secondary income (in US$) of South Africa in 2007 to that in 2010?
Provide a succinct answer. 0.43. What is the ratio of the Secondary income (in US$) of Middle East & North Africa (developing only) in 2007 to that in 2011?
Keep it short and to the point. 0.59. What is the ratio of the Secondary income (in US$) of Austria in 2007 to that in 2011?
Make the answer very short. 0.86. What is the ratio of the Secondary income (in US$) of South Africa in 2007 to that in 2011?
Offer a very short reply. 0.38. What is the ratio of the Secondary income (in US$) in Middle East & North Africa (developing only) in 2007 to that in 2012?
Your answer should be compact. 0.46. What is the ratio of the Secondary income (in US$) of Austria in 2007 to that in 2012?
Make the answer very short. 0.84. What is the ratio of the Secondary income (in US$) of South Africa in 2007 to that in 2012?
Make the answer very short. 0.3. What is the ratio of the Secondary income (in US$) of Middle East & North Africa (developing only) in 2007 to that in 2013?
Ensure brevity in your answer.  0.44. What is the ratio of the Secondary income (in US$) in Austria in 2007 to that in 2013?
Offer a very short reply. 0.78. What is the ratio of the Secondary income (in US$) in South Africa in 2007 to that in 2013?
Ensure brevity in your answer.  0.42. What is the ratio of the Secondary income (in US$) in Middle East & North Africa (developing only) in 2008 to that in 2009?
Make the answer very short. 0.79. What is the ratio of the Secondary income (in US$) of Austria in 2008 to that in 2009?
Keep it short and to the point. 1.24. What is the ratio of the Secondary income (in US$) of South Africa in 2008 to that in 2009?
Your answer should be compact. 0.67. What is the ratio of the Secondary income (in US$) in Middle East & North Africa (developing only) in 2008 to that in 2010?
Provide a short and direct response. 0.67. What is the ratio of the Secondary income (in US$) of Austria in 2008 to that in 2010?
Provide a short and direct response. 1.31. What is the ratio of the Secondary income (in US$) of South Africa in 2008 to that in 2010?
Offer a terse response. 0.61. What is the ratio of the Secondary income (in US$) of Middle East & North Africa (developing only) in 2008 to that in 2011?
Your response must be concise. 0.74. What is the ratio of the Secondary income (in US$) of Austria in 2008 to that in 2011?
Give a very brief answer. 1.21. What is the ratio of the Secondary income (in US$) of South Africa in 2008 to that in 2011?
Your answer should be very brief. 0.53. What is the ratio of the Secondary income (in US$) of Middle East & North Africa (developing only) in 2008 to that in 2012?
Ensure brevity in your answer.  0.58. What is the ratio of the Secondary income (in US$) of Austria in 2008 to that in 2012?
Your response must be concise. 1.18. What is the ratio of the Secondary income (in US$) of South Africa in 2008 to that in 2012?
Offer a very short reply. 0.42. What is the ratio of the Secondary income (in US$) in Middle East & North Africa (developing only) in 2008 to that in 2013?
Ensure brevity in your answer.  0.56. What is the ratio of the Secondary income (in US$) in Austria in 2008 to that in 2013?
Provide a short and direct response. 1.09. What is the ratio of the Secondary income (in US$) in South Africa in 2008 to that in 2013?
Ensure brevity in your answer.  0.59. What is the ratio of the Secondary income (in US$) in Middle East & North Africa (developing only) in 2009 to that in 2010?
Ensure brevity in your answer.  0.85. What is the ratio of the Secondary income (in US$) of Austria in 2009 to that in 2010?
Provide a short and direct response. 1.05. What is the ratio of the Secondary income (in US$) of South Africa in 2009 to that in 2010?
Your answer should be compact. 0.91. What is the ratio of the Secondary income (in US$) of Middle East & North Africa (developing only) in 2009 to that in 2011?
Offer a terse response. 0.95. What is the ratio of the Secondary income (in US$) in Austria in 2009 to that in 2011?
Keep it short and to the point. 0.97. What is the ratio of the Secondary income (in US$) of South Africa in 2009 to that in 2011?
Your answer should be compact. 0.79. What is the ratio of the Secondary income (in US$) of Middle East & North Africa (developing only) in 2009 to that in 2012?
Provide a short and direct response. 0.74. What is the ratio of the Secondary income (in US$) of Austria in 2009 to that in 2012?
Your answer should be very brief. 0.95. What is the ratio of the Secondary income (in US$) in South Africa in 2009 to that in 2012?
Your response must be concise. 0.62. What is the ratio of the Secondary income (in US$) in Middle East & North Africa (developing only) in 2009 to that in 2013?
Provide a succinct answer. 0.71. What is the ratio of the Secondary income (in US$) in Austria in 2009 to that in 2013?
Keep it short and to the point. 0.88. What is the ratio of the Secondary income (in US$) of South Africa in 2009 to that in 2013?
Ensure brevity in your answer.  0.88. What is the ratio of the Secondary income (in US$) of Middle East & North Africa (developing only) in 2010 to that in 2011?
Provide a succinct answer. 1.11. What is the ratio of the Secondary income (in US$) of Austria in 2010 to that in 2011?
Your response must be concise. 0.92. What is the ratio of the Secondary income (in US$) in South Africa in 2010 to that in 2011?
Keep it short and to the point. 0.87. What is the ratio of the Secondary income (in US$) in Middle East & North Africa (developing only) in 2010 to that in 2012?
Your answer should be very brief. 0.87. What is the ratio of the Secondary income (in US$) of Austria in 2010 to that in 2012?
Your answer should be compact. 0.91. What is the ratio of the Secondary income (in US$) in South Africa in 2010 to that in 2012?
Your answer should be very brief. 0.69. What is the ratio of the Secondary income (in US$) in Middle East & North Africa (developing only) in 2010 to that in 2013?
Offer a terse response. 0.83. What is the ratio of the Secondary income (in US$) in Austria in 2010 to that in 2013?
Offer a very short reply. 0.84. What is the ratio of the Secondary income (in US$) in South Africa in 2010 to that in 2013?
Your answer should be compact. 0.97. What is the ratio of the Secondary income (in US$) in Middle East & North Africa (developing only) in 2011 to that in 2012?
Offer a very short reply. 0.79. What is the ratio of the Secondary income (in US$) in Austria in 2011 to that in 2012?
Provide a succinct answer. 0.98. What is the ratio of the Secondary income (in US$) in South Africa in 2011 to that in 2012?
Your answer should be very brief. 0.79. What is the ratio of the Secondary income (in US$) of Middle East & North Africa (developing only) in 2011 to that in 2013?
Make the answer very short. 0.75. What is the ratio of the Secondary income (in US$) of Austria in 2011 to that in 2013?
Your answer should be very brief. 0.91. What is the ratio of the Secondary income (in US$) of South Africa in 2011 to that in 2013?
Your answer should be very brief. 1.12. What is the ratio of the Secondary income (in US$) of Middle East & North Africa (developing only) in 2012 to that in 2013?
Give a very brief answer. 0.95. What is the ratio of the Secondary income (in US$) in Austria in 2012 to that in 2013?
Offer a very short reply. 0.92. What is the ratio of the Secondary income (in US$) of South Africa in 2012 to that in 2013?
Your answer should be very brief. 1.41. What is the difference between the highest and the second highest Secondary income (in US$) in Middle East & North Africa (developing only)?
Provide a short and direct response. 5.59e+08. What is the difference between the highest and the second highest Secondary income (in US$) of Austria?
Provide a short and direct response. 2.46e+08. What is the difference between the highest and the second highest Secondary income (in US$) of South Africa?
Your answer should be compact. 2.21e+08. What is the difference between the highest and the lowest Secondary income (in US$) in Middle East & North Africa (developing only)?
Provide a short and direct response. 6.38e+09. What is the difference between the highest and the lowest Secondary income (in US$) of Austria?
Give a very brief answer. 1.04e+09. What is the difference between the highest and the lowest Secondary income (in US$) in South Africa?
Keep it short and to the point. 8.10e+08. 